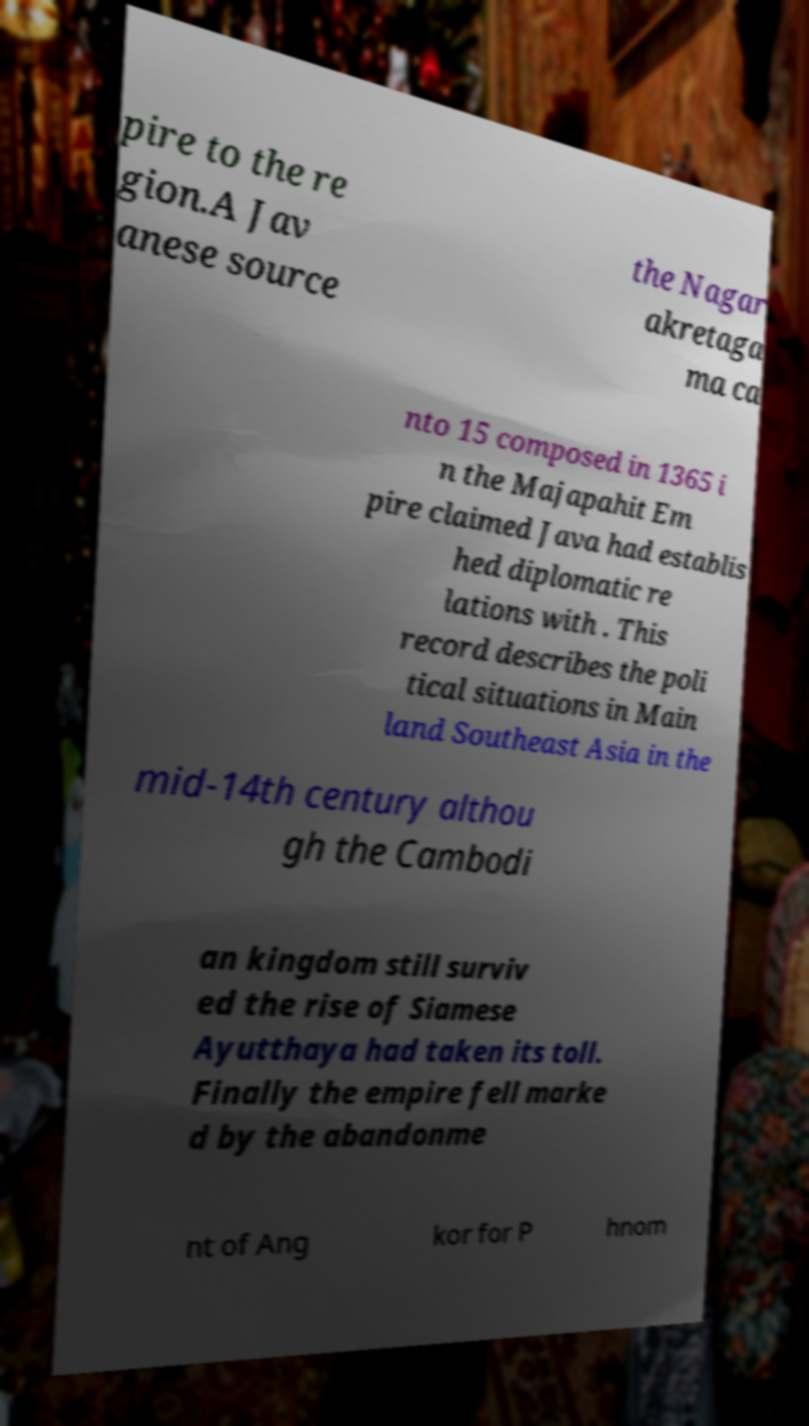There's text embedded in this image that I need extracted. Can you transcribe it verbatim? pire to the re gion.A Jav anese source the Nagar akretaga ma ca nto 15 composed in 1365 i n the Majapahit Em pire claimed Java had establis hed diplomatic re lations with . This record describes the poli tical situations in Main land Southeast Asia in the mid-14th century althou gh the Cambodi an kingdom still surviv ed the rise of Siamese Ayutthaya had taken its toll. Finally the empire fell marke d by the abandonme nt of Ang kor for P hnom 